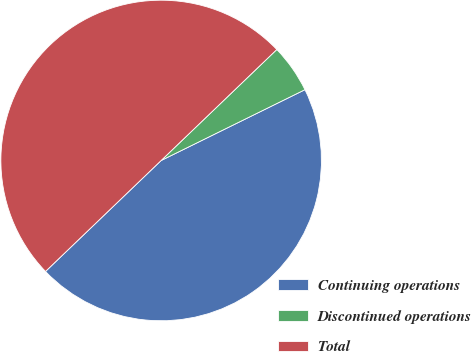<chart> <loc_0><loc_0><loc_500><loc_500><pie_chart><fcel>Continuing operations<fcel>Discontinued operations<fcel>Total<nl><fcel>45.11%<fcel>4.89%<fcel>50.0%<nl></chart> 